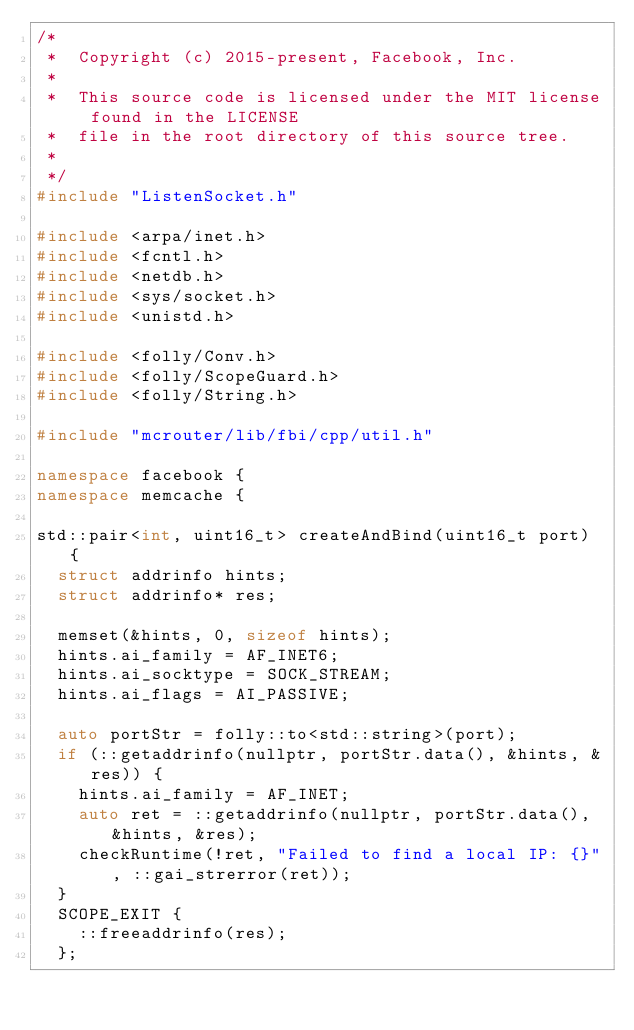Convert code to text. <code><loc_0><loc_0><loc_500><loc_500><_C++_>/*
 *  Copyright (c) 2015-present, Facebook, Inc.
 *
 *  This source code is licensed under the MIT license found in the LICENSE
 *  file in the root directory of this source tree.
 *
 */
#include "ListenSocket.h"

#include <arpa/inet.h>
#include <fcntl.h>
#include <netdb.h>
#include <sys/socket.h>
#include <unistd.h>

#include <folly/Conv.h>
#include <folly/ScopeGuard.h>
#include <folly/String.h>

#include "mcrouter/lib/fbi/cpp/util.h"

namespace facebook {
namespace memcache {

std::pair<int, uint16_t> createAndBind(uint16_t port) {
  struct addrinfo hints;
  struct addrinfo* res;

  memset(&hints, 0, sizeof hints);
  hints.ai_family = AF_INET6;
  hints.ai_socktype = SOCK_STREAM;
  hints.ai_flags = AI_PASSIVE;

  auto portStr = folly::to<std::string>(port);
  if (::getaddrinfo(nullptr, portStr.data(), &hints, &res)) {
    hints.ai_family = AF_INET;
    auto ret = ::getaddrinfo(nullptr, portStr.data(), &hints, &res);
    checkRuntime(!ret, "Failed to find a local IP: {}", ::gai_strerror(ret));
  }
  SCOPE_EXIT {
    ::freeaddrinfo(res);
  };
</code> 